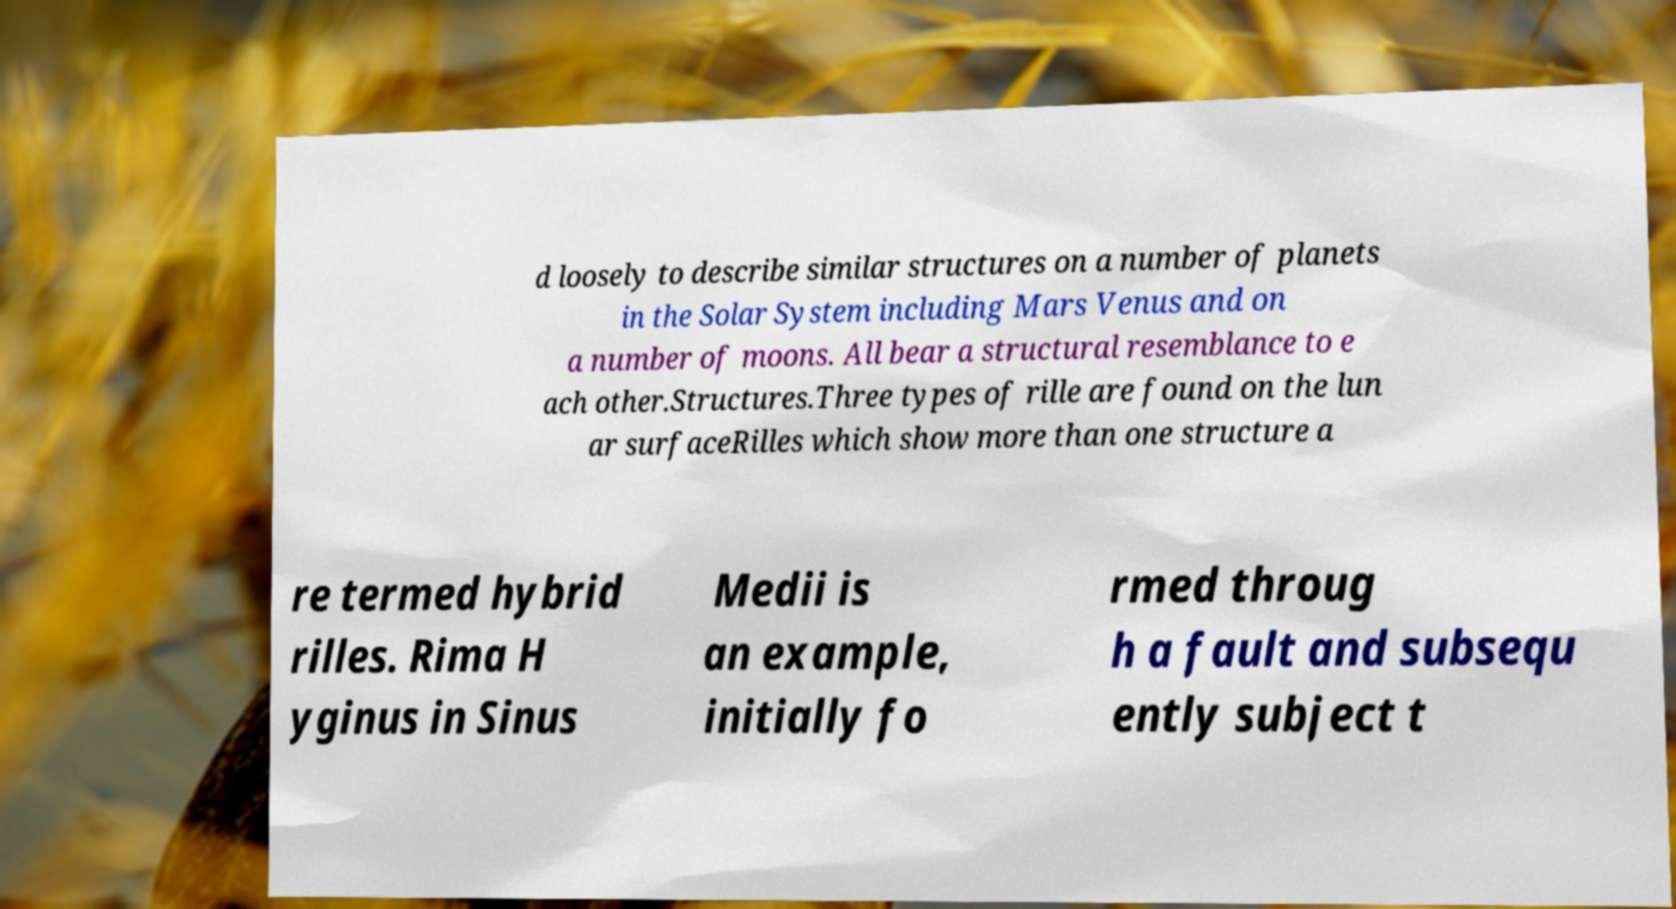Could you extract and type out the text from this image? d loosely to describe similar structures on a number of planets in the Solar System including Mars Venus and on a number of moons. All bear a structural resemblance to e ach other.Structures.Three types of rille are found on the lun ar surfaceRilles which show more than one structure a re termed hybrid rilles. Rima H yginus in Sinus Medii is an example, initially fo rmed throug h a fault and subsequ ently subject t 